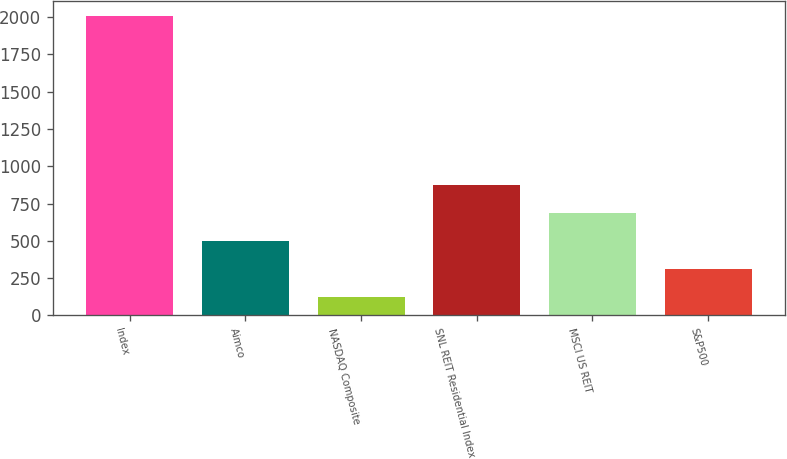Convert chart. <chart><loc_0><loc_0><loc_500><loc_500><bar_chart><fcel>Index<fcel>Aimco<fcel>NASDAQ Composite<fcel>SNL REIT Residential Index<fcel>MSCI US REIT<fcel>S&P500<nl><fcel>2006<fcel>497.64<fcel>120.56<fcel>874.72<fcel>686.18<fcel>309.1<nl></chart> 